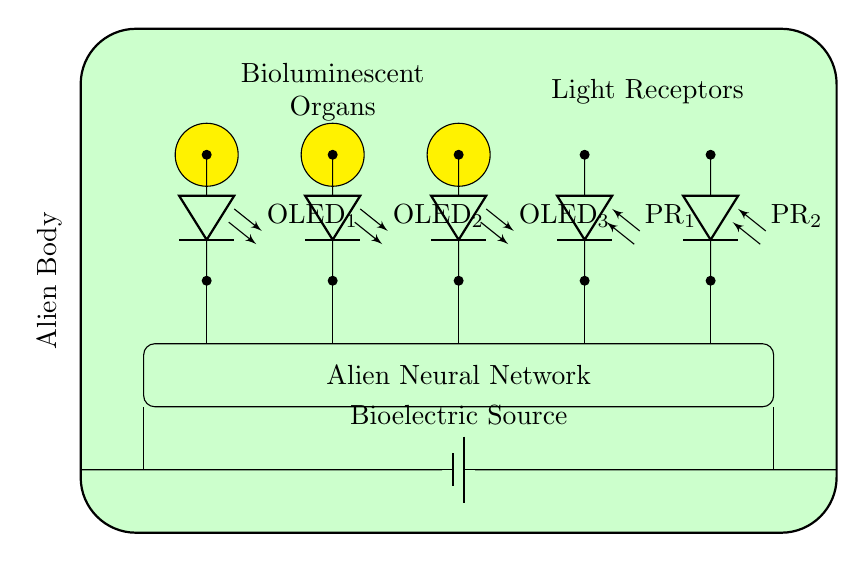What components are present in the circuit diagram? The circuit diagram includes bioluminescent organs, organic LEDs, photoreceptors, a neural network, and a bioelectric source.
Answer: bioluminescent organs, organic LEDs, photoreceptors, neural network, bioelectric source How many organic LEDs are there in the circuit? From the diagram, there are three organic LEDs labeled OLED1, OLED2, and OLED3.
Answer: three What is the function of the photoreceptors in the circuit? The photoreceptors, labeled PR1 and PR2, detect light emitted by the organic LEDs and send signals to the alien neural network for communication.
Answer: detect light Describe the connection role between the organic LEDs and the neural network. The organic LEDs are connected to the neural network, indicating they emit light used for communication, which is then processed by the neural network.
Answer: light emission What does the bioelectric source provide to the circuit? The bioelectric source acts as the power supply for the entire circuit, powering all connected components including the organic LEDs and photoreceptors.
Answer: power supply How does the information flow from the organic LEDs to the neural network? Information flows through connections; the light emitted from each organic LED is connected to the neural network, which processes the signals received from the photoreceptors.
Answer: through connections What role do the organic light-emitting diodes serve in the communication system? The organic light-emitting diodes serve as the primary light emitters allowing the alien to transmit signals through bioluminescence in communication with other organisms.
Answer: transmit signals 